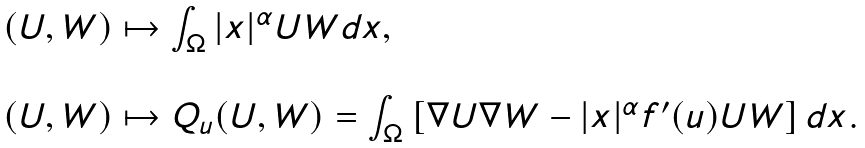Convert formula to latex. <formula><loc_0><loc_0><loc_500><loc_500>\begin{array} { l } ( U , W ) \mapsto \int _ { \Omega } | x | ^ { \alpha } U W d x , \\ \\ ( U , W ) \mapsto Q _ { u } ( U , W ) = \int _ { \Omega } \left [ \nabla U \nabla W - | x | ^ { \alpha } f ^ { \prime } ( u ) U W \right ] d x . \end{array}</formula> 